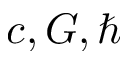<formula> <loc_0><loc_0><loc_500><loc_500>c , G , \hbar</formula> 